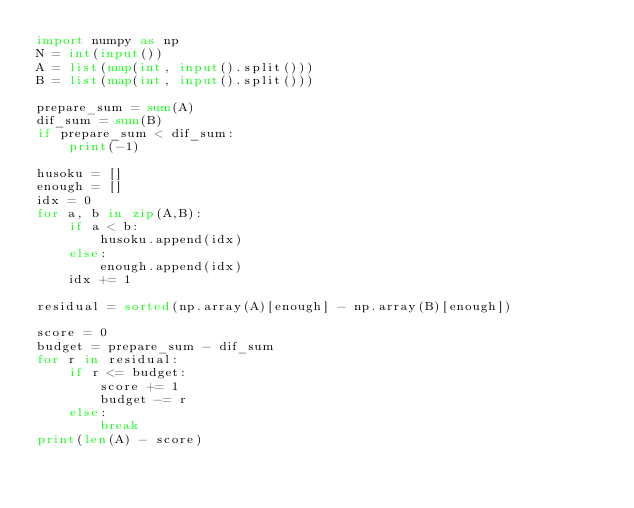<code> <loc_0><loc_0><loc_500><loc_500><_Python_>import numpy as np
N = int(input())
A = list(map(int, input().split()))
B = list(map(int, input().split()))

prepare_sum = sum(A)
dif_sum = sum(B)
if prepare_sum < dif_sum:
    print(-1)

husoku = []
enough = []
idx = 0
for a, b in zip(A,B):
    if a < b:
        husoku.append(idx)
    else:
        enough.append(idx)
    idx += 1
    
residual = sorted(np.array(A)[enough] - np.array(B)[enough])

score = 0
budget = prepare_sum - dif_sum
for r in residual:
    if r <= budget:
        score += 1
        budget -= r
    else:
        break
print(len(A) - score)</code> 